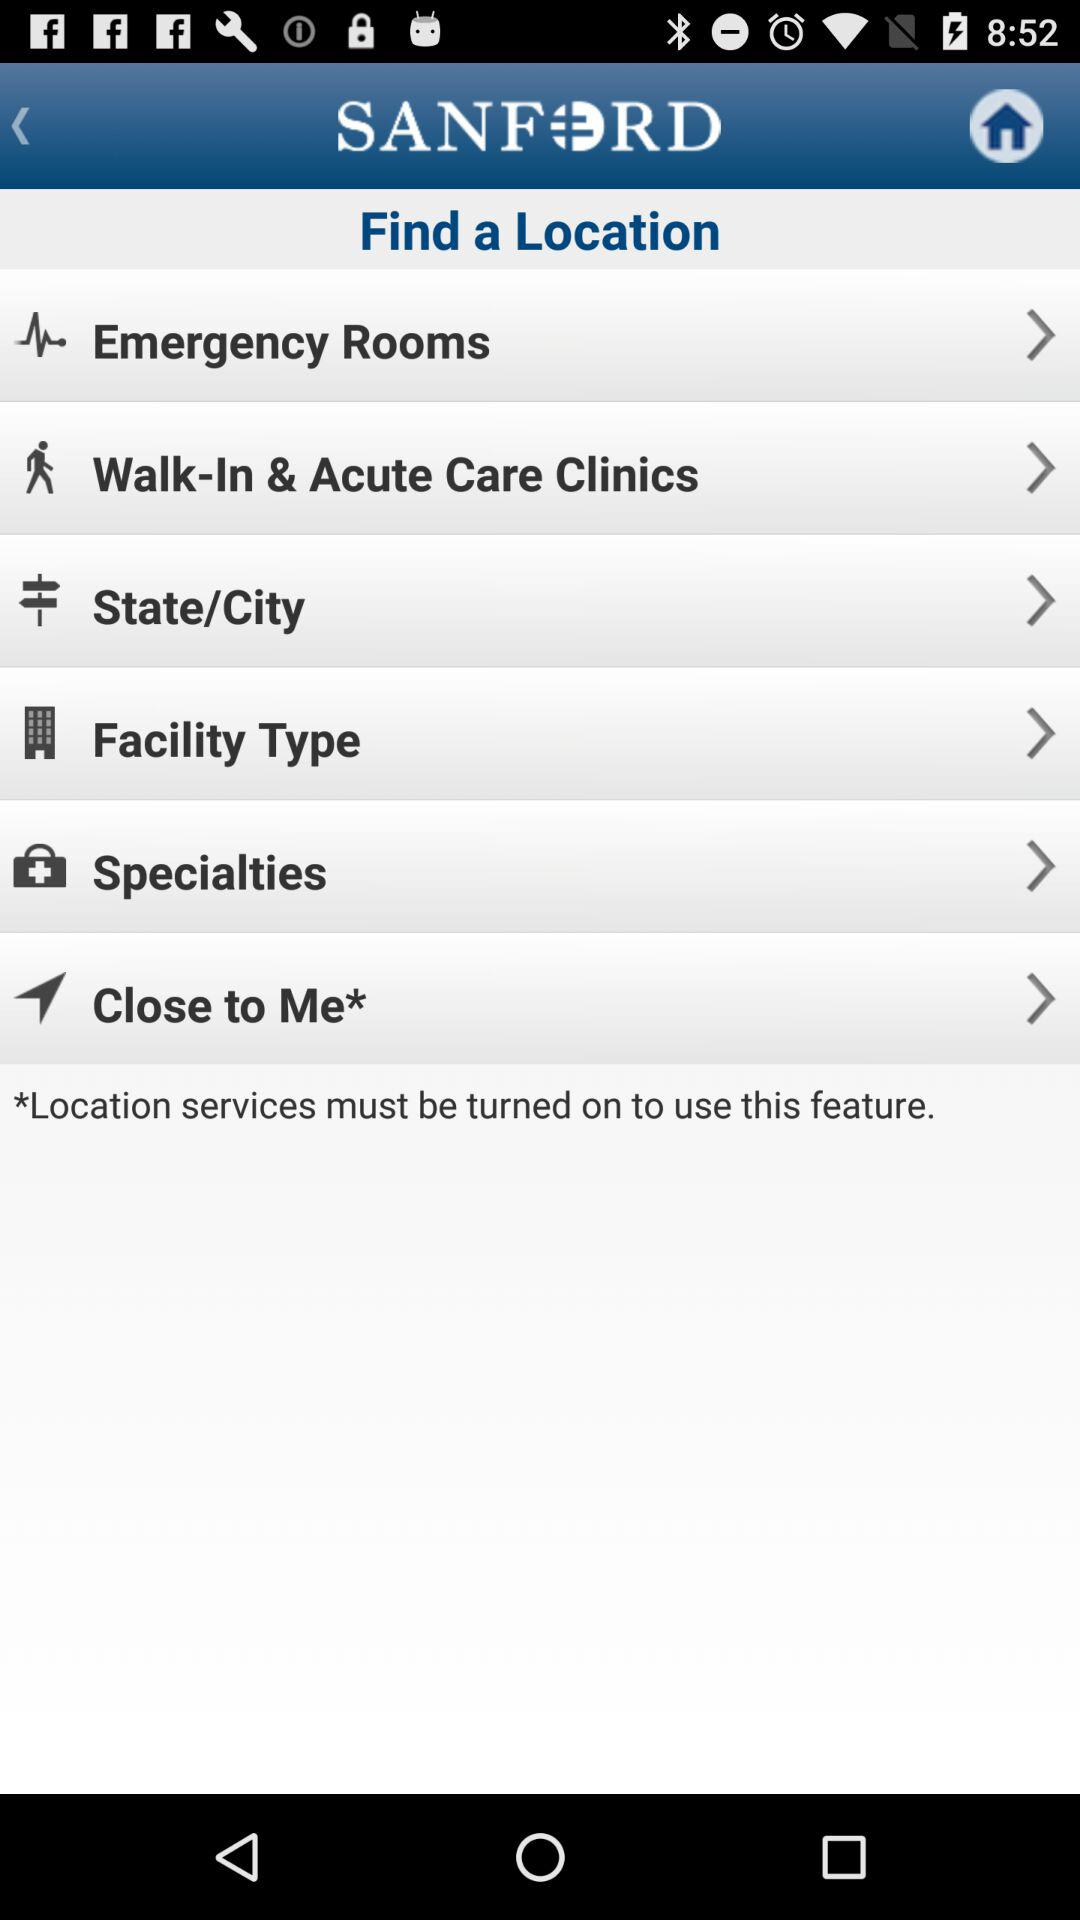Which categories are displayed under which to find a location bar? The categories are "Emergency Rooms", "Walk-In & Acute Care Clinics", "State/City", "Facility Type", "Specialties", and "Close to Me*". 